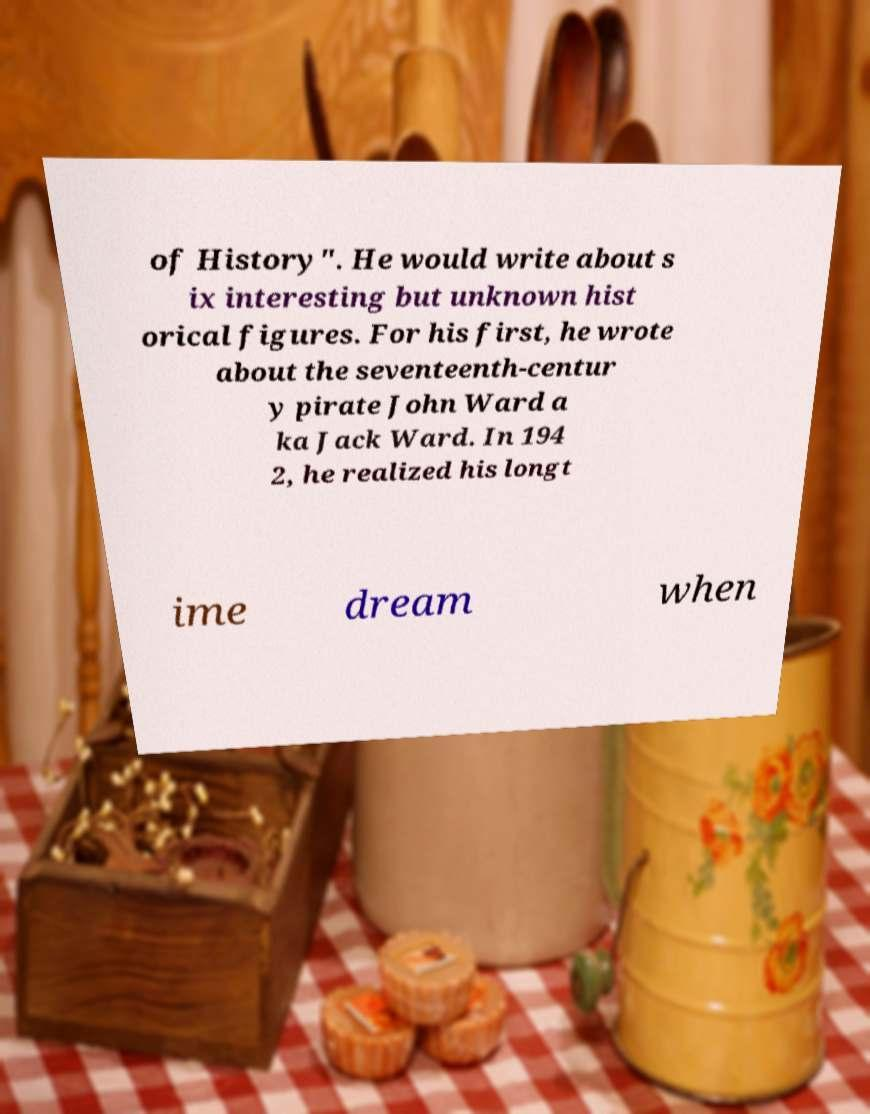For documentation purposes, I need the text within this image transcribed. Could you provide that? of History". He would write about s ix interesting but unknown hist orical figures. For his first, he wrote about the seventeenth-centur y pirate John Ward a ka Jack Ward. In 194 2, he realized his longt ime dream when 